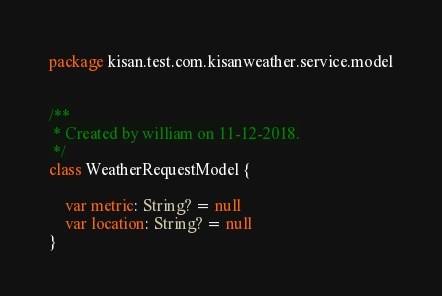<code> <loc_0><loc_0><loc_500><loc_500><_Kotlin_>package kisan.test.com.kisanweather.service.model


/**
 * Created by william on 11-12-2018.
 */
class WeatherRequestModel {

    var metric: String? = null
    var location: String? = null
}
</code> 